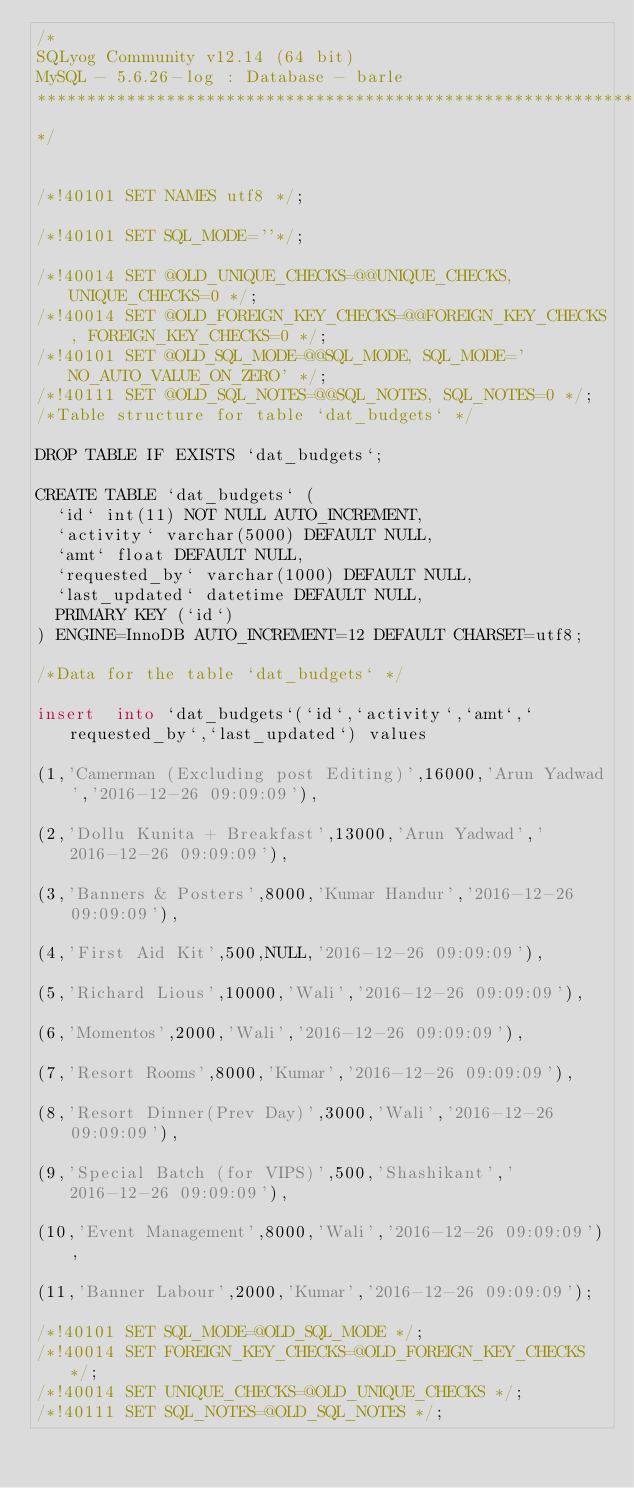<code> <loc_0><loc_0><loc_500><loc_500><_SQL_>/*
SQLyog Community v12.14 (64 bit)
MySQL - 5.6.26-log : Database - barle
*********************************************************************
*/

/*!40101 SET NAMES utf8 */;

/*!40101 SET SQL_MODE=''*/;

/*!40014 SET @OLD_UNIQUE_CHECKS=@@UNIQUE_CHECKS, UNIQUE_CHECKS=0 */;
/*!40014 SET @OLD_FOREIGN_KEY_CHECKS=@@FOREIGN_KEY_CHECKS, FOREIGN_KEY_CHECKS=0 */;
/*!40101 SET @OLD_SQL_MODE=@@SQL_MODE, SQL_MODE='NO_AUTO_VALUE_ON_ZERO' */;
/*!40111 SET @OLD_SQL_NOTES=@@SQL_NOTES, SQL_NOTES=0 */;
/*Table structure for table `dat_budgets` */

DROP TABLE IF EXISTS `dat_budgets`;

CREATE TABLE `dat_budgets` (
  `id` int(11) NOT NULL AUTO_INCREMENT,
  `activity` varchar(5000) DEFAULT NULL,
  `amt` float DEFAULT NULL,
  `requested_by` varchar(1000) DEFAULT NULL,
  `last_updated` datetime DEFAULT NULL,
  PRIMARY KEY (`id`)
) ENGINE=InnoDB AUTO_INCREMENT=12 DEFAULT CHARSET=utf8;

/*Data for the table `dat_budgets` */

insert  into `dat_budgets`(`id`,`activity`,`amt`,`requested_by`,`last_updated`) values 
(1,'Camerman (Excluding post Editing)',16000,'Arun Yadwad','2016-12-26 09:09:09'),
(2,'Dollu Kunita + Breakfast',13000,'Arun Yadwad','2016-12-26 09:09:09'),
(3,'Banners & Posters',8000,'Kumar Handur','2016-12-26 09:09:09'),
(4,'First Aid Kit',500,NULL,'2016-12-26 09:09:09'),
(5,'Richard Lious',10000,'Wali','2016-12-26 09:09:09'),
(6,'Momentos',2000,'Wali','2016-12-26 09:09:09'),
(7,'Resort Rooms',8000,'Kumar','2016-12-26 09:09:09'),
(8,'Resort Dinner(Prev Day)',3000,'Wali','2016-12-26 09:09:09'),
(9,'Special Batch (for VIPS)',500,'Shashikant','2016-12-26 09:09:09'),
(10,'Event Management',8000,'Wali','2016-12-26 09:09:09'),
(11,'Banner Labour',2000,'Kumar','2016-12-26 09:09:09');

/*!40101 SET SQL_MODE=@OLD_SQL_MODE */;
/*!40014 SET FOREIGN_KEY_CHECKS=@OLD_FOREIGN_KEY_CHECKS */;
/*!40014 SET UNIQUE_CHECKS=@OLD_UNIQUE_CHECKS */;
/*!40111 SET SQL_NOTES=@OLD_SQL_NOTES */;
</code> 